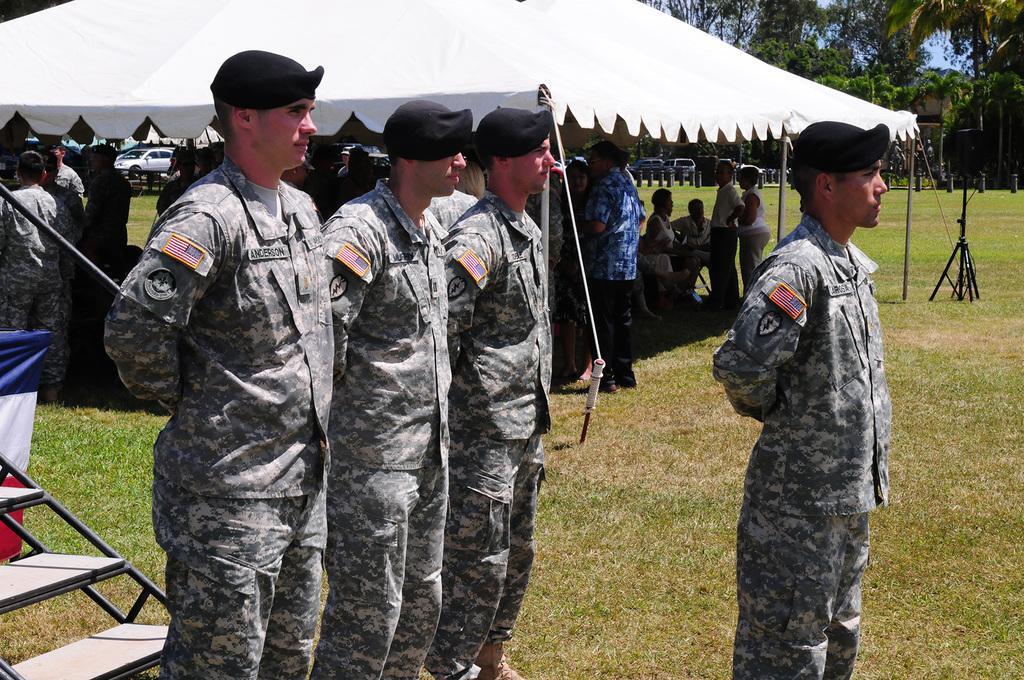How would you summarize this image in a sentence or two? In this image there are a few army personnel standing, behind them under a tent there are a few other army personnel, in the background of the image there are cars parked and there are trees. 